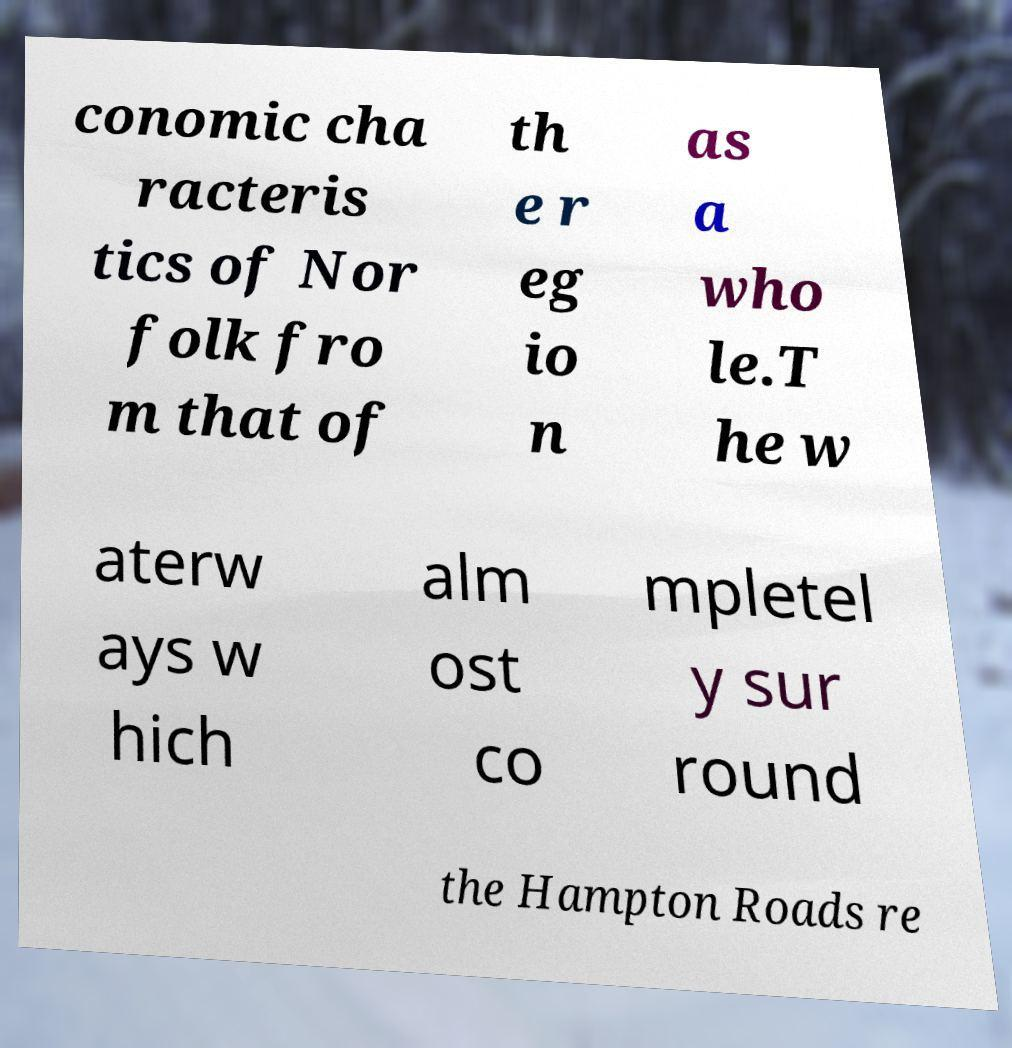I need the written content from this picture converted into text. Can you do that? conomic cha racteris tics of Nor folk fro m that of th e r eg io n as a who le.T he w aterw ays w hich alm ost co mpletel y sur round the Hampton Roads re 